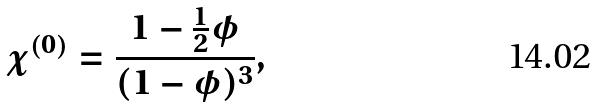<formula> <loc_0><loc_0><loc_500><loc_500>\chi ^ { ( 0 ) } = \frac { 1 - \frac { 1 } { 2 } \phi } { ( 1 - \phi ) ^ { 3 } } ,</formula> 